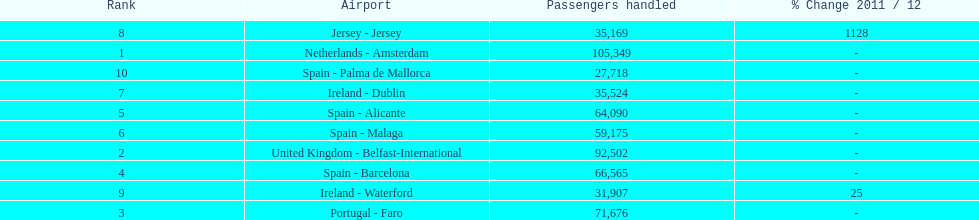How many airports are listed? 10. 